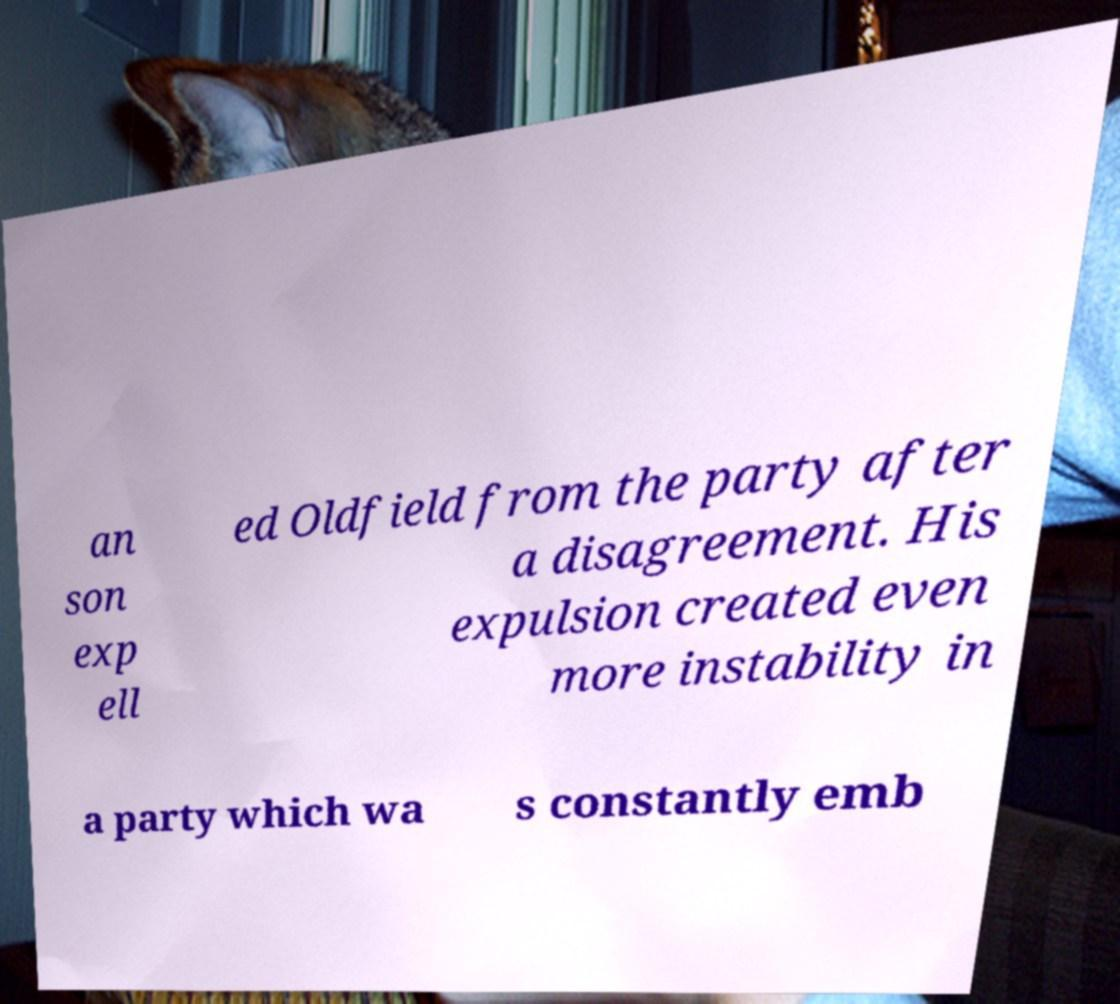I need the written content from this picture converted into text. Can you do that? an son exp ell ed Oldfield from the party after a disagreement. His expulsion created even more instability in a party which wa s constantly emb 